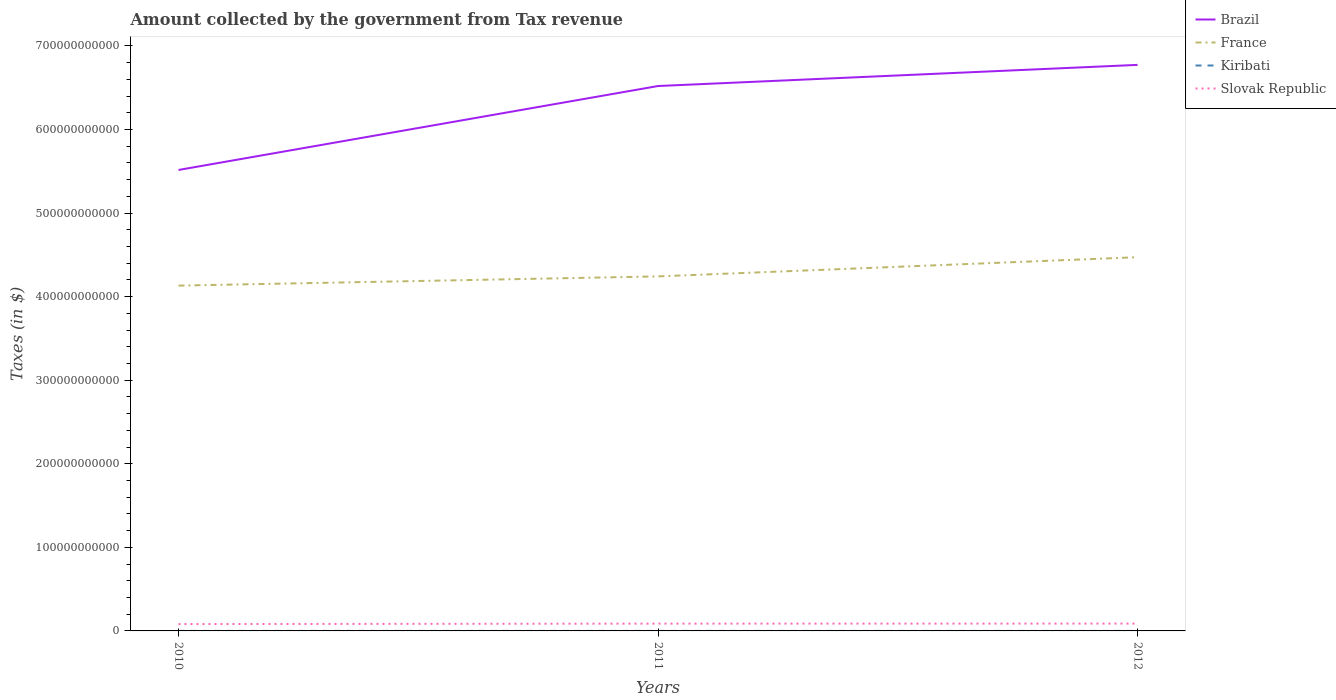Does the line corresponding to Brazil intersect with the line corresponding to Slovak Republic?
Offer a very short reply. No. Across all years, what is the maximum amount collected by the government from tax revenue in Brazil?
Ensure brevity in your answer.  5.52e+11. What is the total amount collected by the government from tax revenue in Kiribati in the graph?
Provide a short and direct response. 1.41e+05. What is the difference between the highest and the second highest amount collected by the government from tax revenue in Brazil?
Keep it short and to the point. 1.26e+11. What is the difference between the highest and the lowest amount collected by the government from tax revenue in France?
Your answer should be compact. 1. What is the difference between two consecutive major ticks on the Y-axis?
Ensure brevity in your answer.  1.00e+11. Are the values on the major ticks of Y-axis written in scientific E-notation?
Give a very brief answer. No. How are the legend labels stacked?
Ensure brevity in your answer.  Vertical. What is the title of the graph?
Your response must be concise. Amount collected by the government from Tax revenue. Does "Equatorial Guinea" appear as one of the legend labels in the graph?
Your answer should be very brief. No. What is the label or title of the Y-axis?
Give a very brief answer. Taxes (in $). What is the Taxes (in $) of Brazil in 2010?
Give a very brief answer. 5.52e+11. What is the Taxes (in $) in France in 2010?
Provide a short and direct response. 4.13e+11. What is the Taxes (in $) of Kiribati in 2010?
Your response must be concise. 2.67e+07. What is the Taxes (in $) of Slovak Republic in 2010?
Offer a terse response. 8.20e+09. What is the Taxes (in $) of Brazil in 2011?
Provide a short and direct response. 6.52e+11. What is the Taxes (in $) in France in 2011?
Make the answer very short. 4.24e+11. What is the Taxes (in $) in Kiribati in 2011?
Offer a very short reply. 2.73e+07. What is the Taxes (in $) in Slovak Republic in 2011?
Provide a succinct answer. 8.75e+09. What is the Taxes (in $) in Brazil in 2012?
Ensure brevity in your answer.  6.77e+11. What is the Taxes (in $) in France in 2012?
Your answer should be compact. 4.47e+11. What is the Taxes (in $) in Kiribati in 2012?
Your answer should be compact. 2.71e+07. What is the Taxes (in $) in Slovak Republic in 2012?
Give a very brief answer. 8.79e+09. Across all years, what is the maximum Taxes (in $) in Brazil?
Ensure brevity in your answer.  6.77e+11. Across all years, what is the maximum Taxes (in $) of France?
Your answer should be compact. 4.47e+11. Across all years, what is the maximum Taxes (in $) in Kiribati?
Provide a short and direct response. 2.73e+07. Across all years, what is the maximum Taxes (in $) of Slovak Republic?
Provide a succinct answer. 8.79e+09. Across all years, what is the minimum Taxes (in $) in Brazil?
Offer a very short reply. 5.52e+11. Across all years, what is the minimum Taxes (in $) in France?
Make the answer very short. 4.13e+11. Across all years, what is the minimum Taxes (in $) in Kiribati?
Offer a very short reply. 2.67e+07. Across all years, what is the minimum Taxes (in $) in Slovak Republic?
Offer a terse response. 8.20e+09. What is the total Taxes (in $) in Brazil in the graph?
Provide a short and direct response. 1.88e+12. What is the total Taxes (in $) of France in the graph?
Give a very brief answer. 1.28e+12. What is the total Taxes (in $) of Kiribati in the graph?
Ensure brevity in your answer.  8.11e+07. What is the total Taxes (in $) in Slovak Republic in the graph?
Your answer should be compact. 2.57e+1. What is the difference between the Taxes (in $) in Brazil in 2010 and that in 2011?
Make the answer very short. -1.00e+11. What is the difference between the Taxes (in $) in France in 2010 and that in 2011?
Give a very brief answer. -1.10e+1. What is the difference between the Taxes (in $) of Kiribati in 2010 and that in 2011?
Your response must be concise. -5.32e+05. What is the difference between the Taxes (in $) of Slovak Republic in 2010 and that in 2011?
Provide a succinct answer. -5.49e+08. What is the difference between the Taxes (in $) in Brazil in 2010 and that in 2012?
Provide a short and direct response. -1.26e+11. What is the difference between the Taxes (in $) in France in 2010 and that in 2012?
Your answer should be very brief. -3.40e+1. What is the difference between the Taxes (in $) of Kiribati in 2010 and that in 2012?
Offer a very short reply. -3.91e+05. What is the difference between the Taxes (in $) in Slovak Republic in 2010 and that in 2012?
Offer a very short reply. -5.82e+08. What is the difference between the Taxes (in $) in Brazil in 2011 and that in 2012?
Give a very brief answer. -2.53e+1. What is the difference between the Taxes (in $) in France in 2011 and that in 2012?
Keep it short and to the point. -2.30e+1. What is the difference between the Taxes (in $) in Kiribati in 2011 and that in 2012?
Keep it short and to the point. 1.41e+05. What is the difference between the Taxes (in $) of Slovak Republic in 2011 and that in 2012?
Provide a short and direct response. -3.32e+07. What is the difference between the Taxes (in $) of Brazil in 2010 and the Taxes (in $) of France in 2011?
Give a very brief answer. 1.27e+11. What is the difference between the Taxes (in $) of Brazil in 2010 and the Taxes (in $) of Kiribati in 2011?
Give a very brief answer. 5.52e+11. What is the difference between the Taxes (in $) of Brazil in 2010 and the Taxes (in $) of Slovak Republic in 2011?
Provide a short and direct response. 5.43e+11. What is the difference between the Taxes (in $) in France in 2010 and the Taxes (in $) in Kiribati in 2011?
Ensure brevity in your answer.  4.13e+11. What is the difference between the Taxes (in $) in France in 2010 and the Taxes (in $) in Slovak Republic in 2011?
Ensure brevity in your answer.  4.04e+11. What is the difference between the Taxes (in $) of Kiribati in 2010 and the Taxes (in $) of Slovak Republic in 2011?
Give a very brief answer. -8.73e+09. What is the difference between the Taxes (in $) of Brazil in 2010 and the Taxes (in $) of France in 2012?
Give a very brief answer. 1.04e+11. What is the difference between the Taxes (in $) of Brazil in 2010 and the Taxes (in $) of Kiribati in 2012?
Make the answer very short. 5.52e+11. What is the difference between the Taxes (in $) in Brazil in 2010 and the Taxes (in $) in Slovak Republic in 2012?
Offer a very short reply. 5.43e+11. What is the difference between the Taxes (in $) in France in 2010 and the Taxes (in $) in Kiribati in 2012?
Offer a terse response. 4.13e+11. What is the difference between the Taxes (in $) in France in 2010 and the Taxes (in $) in Slovak Republic in 2012?
Provide a short and direct response. 4.04e+11. What is the difference between the Taxes (in $) in Kiribati in 2010 and the Taxes (in $) in Slovak Republic in 2012?
Give a very brief answer. -8.76e+09. What is the difference between the Taxes (in $) of Brazil in 2011 and the Taxes (in $) of France in 2012?
Your response must be concise. 2.05e+11. What is the difference between the Taxes (in $) of Brazil in 2011 and the Taxes (in $) of Kiribati in 2012?
Ensure brevity in your answer.  6.52e+11. What is the difference between the Taxes (in $) in Brazil in 2011 and the Taxes (in $) in Slovak Republic in 2012?
Offer a terse response. 6.43e+11. What is the difference between the Taxes (in $) of France in 2011 and the Taxes (in $) of Kiribati in 2012?
Keep it short and to the point. 4.24e+11. What is the difference between the Taxes (in $) in France in 2011 and the Taxes (in $) in Slovak Republic in 2012?
Your response must be concise. 4.15e+11. What is the difference between the Taxes (in $) of Kiribati in 2011 and the Taxes (in $) of Slovak Republic in 2012?
Ensure brevity in your answer.  -8.76e+09. What is the average Taxes (in $) of Brazil per year?
Provide a short and direct response. 6.27e+11. What is the average Taxes (in $) of France per year?
Make the answer very short. 4.28e+11. What is the average Taxes (in $) in Kiribati per year?
Keep it short and to the point. 2.70e+07. What is the average Taxes (in $) of Slovak Republic per year?
Your response must be concise. 8.58e+09. In the year 2010, what is the difference between the Taxes (in $) of Brazil and Taxes (in $) of France?
Provide a short and direct response. 1.38e+11. In the year 2010, what is the difference between the Taxes (in $) of Brazil and Taxes (in $) of Kiribati?
Keep it short and to the point. 5.52e+11. In the year 2010, what is the difference between the Taxes (in $) in Brazil and Taxes (in $) in Slovak Republic?
Give a very brief answer. 5.43e+11. In the year 2010, what is the difference between the Taxes (in $) of France and Taxes (in $) of Kiribati?
Give a very brief answer. 4.13e+11. In the year 2010, what is the difference between the Taxes (in $) in France and Taxes (in $) in Slovak Republic?
Provide a succinct answer. 4.05e+11. In the year 2010, what is the difference between the Taxes (in $) in Kiribati and Taxes (in $) in Slovak Republic?
Your answer should be compact. -8.18e+09. In the year 2011, what is the difference between the Taxes (in $) in Brazil and Taxes (in $) in France?
Give a very brief answer. 2.28e+11. In the year 2011, what is the difference between the Taxes (in $) in Brazil and Taxes (in $) in Kiribati?
Provide a short and direct response. 6.52e+11. In the year 2011, what is the difference between the Taxes (in $) in Brazil and Taxes (in $) in Slovak Republic?
Give a very brief answer. 6.43e+11. In the year 2011, what is the difference between the Taxes (in $) of France and Taxes (in $) of Kiribati?
Your response must be concise. 4.24e+11. In the year 2011, what is the difference between the Taxes (in $) of France and Taxes (in $) of Slovak Republic?
Provide a succinct answer. 4.15e+11. In the year 2011, what is the difference between the Taxes (in $) of Kiribati and Taxes (in $) of Slovak Republic?
Your response must be concise. -8.73e+09. In the year 2012, what is the difference between the Taxes (in $) of Brazil and Taxes (in $) of France?
Offer a very short reply. 2.30e+11. In the year 2012, what is the difference between the Taxes (in $) of Brazil and Taxes (in $) of Kiribati?
Keep it short and to the point. 6.77e+11. In the year 2012, what is the difference between the Taxes (in $) of Brazil and Taxes (in $) of Slovak Republic?
Make the answer very short. 6.69e+11. In the year 2012, what is the difference between the Taxes (in $) in France and Taxes (in $) in Kiribati?
Your response must be concise. 4.47e+11. In the year 2012, what is the difference between the Taxes (in $) in France and Taxes (in $) in Slovak Republic?
Give a very brief answer. 4.38e+11. In the year 2012, what is the difference between the Taxes (in $) in Kiribati and Taxes (in $) in Slovak Republic?
Offer a very short reply. -8.76e+09. What is the ratio of the Taxes (in $) of Brazil in 2010 to that in 2011?
Offer a terse response. 0.85. What is the ratio of the Taxes (in $) of France in 2010 to that in 2011?
Your answer should be compact. 0.97. What is the ratio of the Taxes (in $) in Kiribati in 2010 to that in 2011?
Your answer should be very brief. 0.98. What is the ratio of the Taxes (in $) of Slovak Republic in 2010 to that in 2011?
Provide a short and direct response. 0.94. What is the ratio of the Taxes (in $) in Brazil in 2010 to that in 2012?
Your answer should be very brief. 0.81. What is the ratio of the Taxes (in $) of France in 2010 to that in 2012?
Keep it short and to the point. 0.92. What is the ratio of the Taxes (in $) in Kiribati in 2010 to that in 2012?
Offer a terse response. 0.99. What is the ratio of the Taxes (in $) in Slovak Republic in 2010 to that in 2012?
Give a very brief answer. 0.93. What is the ratio of the Taxes (in $) of Brazil in 2011 to that in 2012?
Offer a very short reply. 0.96. What is the ratio of the Taxes (in $) of France in 2011 to that in 2012?
Provide a succinct answer. 0.95. What is the ratio of the Taxes (in $) in Kiribati in 2011 to that in 2012?
Offer a terse response. 1.01. What is the ratio of the Taxes (in $) in Slovak Republic in 2011 to that in 2012?
Your answer should be very brief. 1. What is the difference between the highest and the second highest Taxes (in $) in Brazil?
Make the answer very short. 2.53e+1. What is the difference between the highest and the second highest Taxes (in $) in France?
Your response must be concise. 2.30e+1. What is the difference between the highest and the second highest Taxes (in $) in Kiribati?
Your answer should be compact. 1.41e+05. What is the difference between the highest and the second highest Taxes (in $) in Slovak Republic?
Give a very brief answer. 3.32e+07. What is the difference between the highest and the lowest Taxes (in $) of Brazil?
Offer a very short reply. 1.26e+11. What is the difference between the highest and the lowest Taxes (in $) in France?
Your answer should be compact. 3.40e+1. What is the difference between the highest and the lowest Taxes (in $) in Kiribati?
Keep it short and to the point. 5.32e+05. What is the difference between the highest and the lowest Taxes (in $) of Slovak Republic?
Make the answer very short. 5.82e+08. 